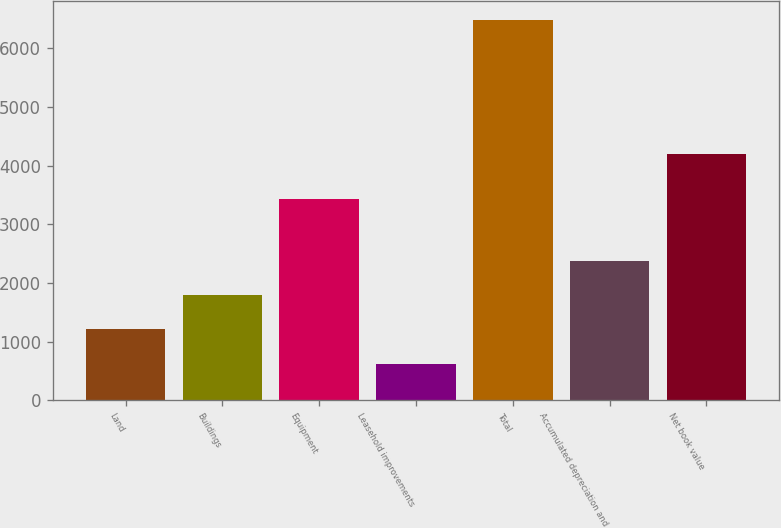<chart> <loc_0><loc_0><loc_500><loc_500><bar_chart><fcel>Land<fcel>Buildings<fcel>Equipment<fcel>Leasehold improvements<fcel>Total<fcel>Accumulated depreciation and<fcel>Net book value<nl><fcel>1210.8<fcel>1795.6<fcel>3423<fcel>626<fcel>6474<fcel>2380.4<fcel>4197<nl></chart> 